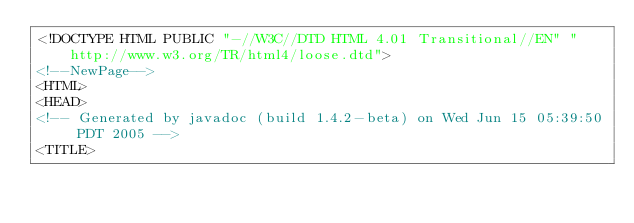<code> <loc_0><loc_0><loc_500><loc_500><_HTML_><!DOCTYPE HTML PUBLIC "-//W3C//DTD HTML 4.01 Transitional//EN" "http://www.w3.org/TR/html4/loose.dtd">
<!--NewPage-->
<HTML>
<HEAD>
<!-- Generated by javadoc (build 1.4.2-beta) on Wed Jun 15 05:39:50 PDT 2005 -->
<TITLE></code> 